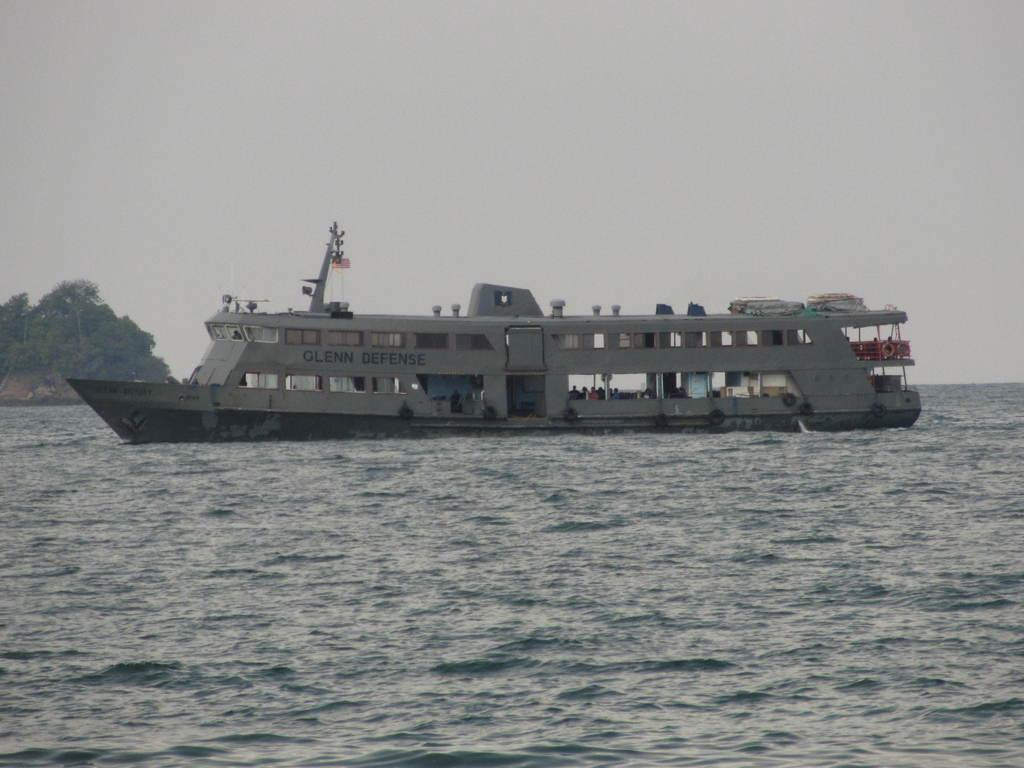What is the main subject in the image? There is a ship in the water. What can be seen in the background of the image? Trees and the sky are visible in the image. How many cents are visible in the image? There are no cents present in the image. What part of the ship is driving the vessel in the image? The image does not show the ship in motion, nor does it depict any specific part of the ship responsible for driving the vessel. 